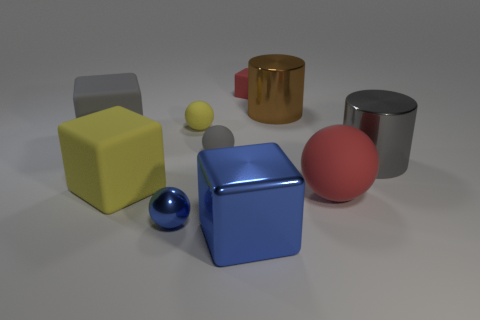Subtract all brown cylinders. Subtract all cyan spheres. How many cylinders are left? 1 Subtract all blocks. How many objects are left? 6 Subtract all big blue objects. Subtract all big gray rubber things. How many objects are left? 8 Add 1 big metal cubes. How many big metal cubes are left? 2 Add 5 red rubber blocks. How many red rubber blocks exist? 6 Subtract 1 red balls. How many objects are left? 9 